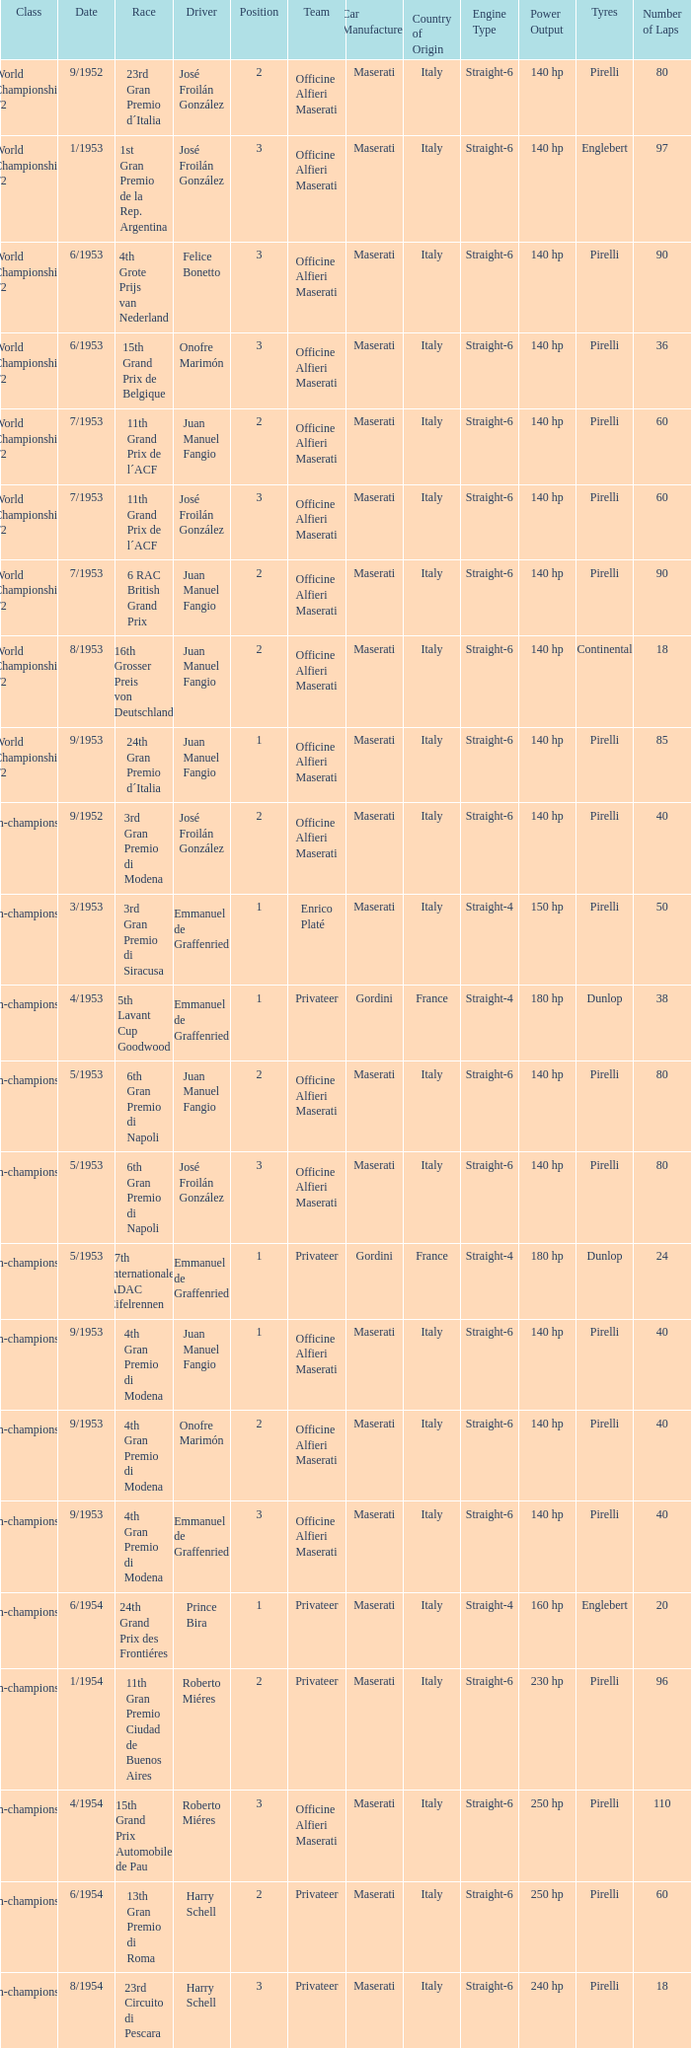What date has the class of non-championship f2 as well as a driver name josé froilán gonzález that has a position larger than 2? 5/1953. 